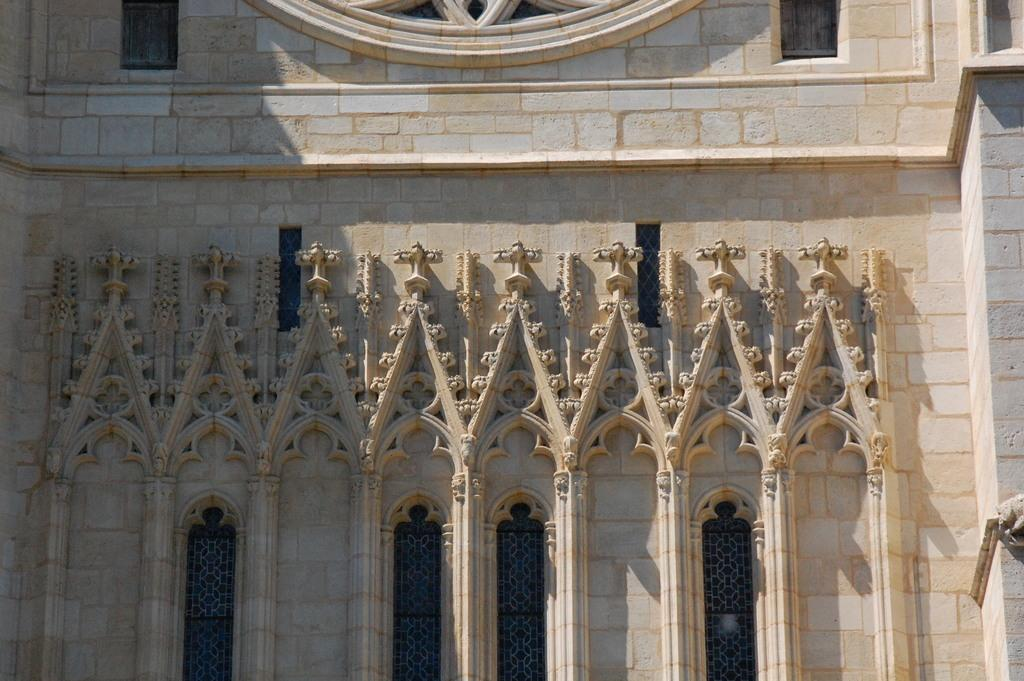What is the main structure visible in the image? There is a building in the image. Can you describe any specific features of the building? The building has multiple windows. What type of animal can be seen playing with the waste near the railway in the image? There is no animal, waste, or railway present in the image; it only features a building with multiple windows. 